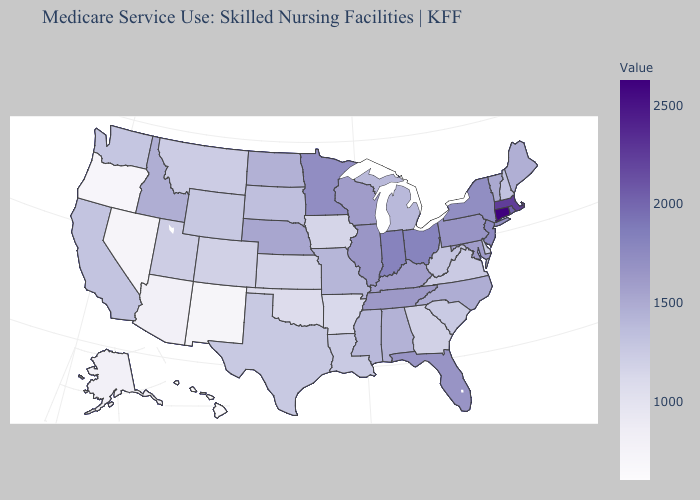Among the states that border Oklahoma , does Missouri have the highest value?
Short answer required. Yes. Does Ohio have a lower value than Connecticut?
Write a very short answer. Yes. Which states have the lowest value in the MidWest?
Concise answer only. Iowa. Which states have the highest value in the USA?
Write a very short answer. Connecticut. 